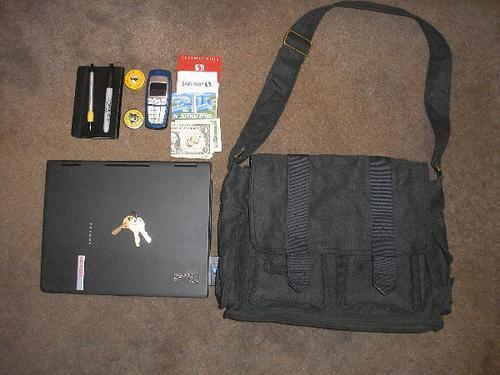What is on the laptop?
Indicate the correct response and explain using: 'Answer: answer
Rationale: rationale.'
Options: Butterfly, cat, egg, keys. Answer: keys.
Rationale: The things on the laptop are made of metal and joined on a ring. 